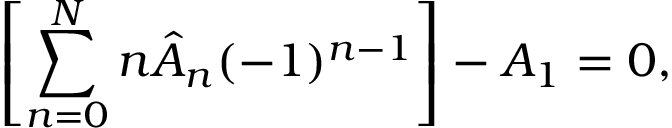Convert formula to latex. <formula><loc_0><loc_0><loc_500><loc_500>\left [ \sum _ { n = 0 } ^ { N } n \hat { A } _ { n } ( - 1 ) ^ { n - 1 } \right ] - A _ { 1 } = 0 ,</formula> 